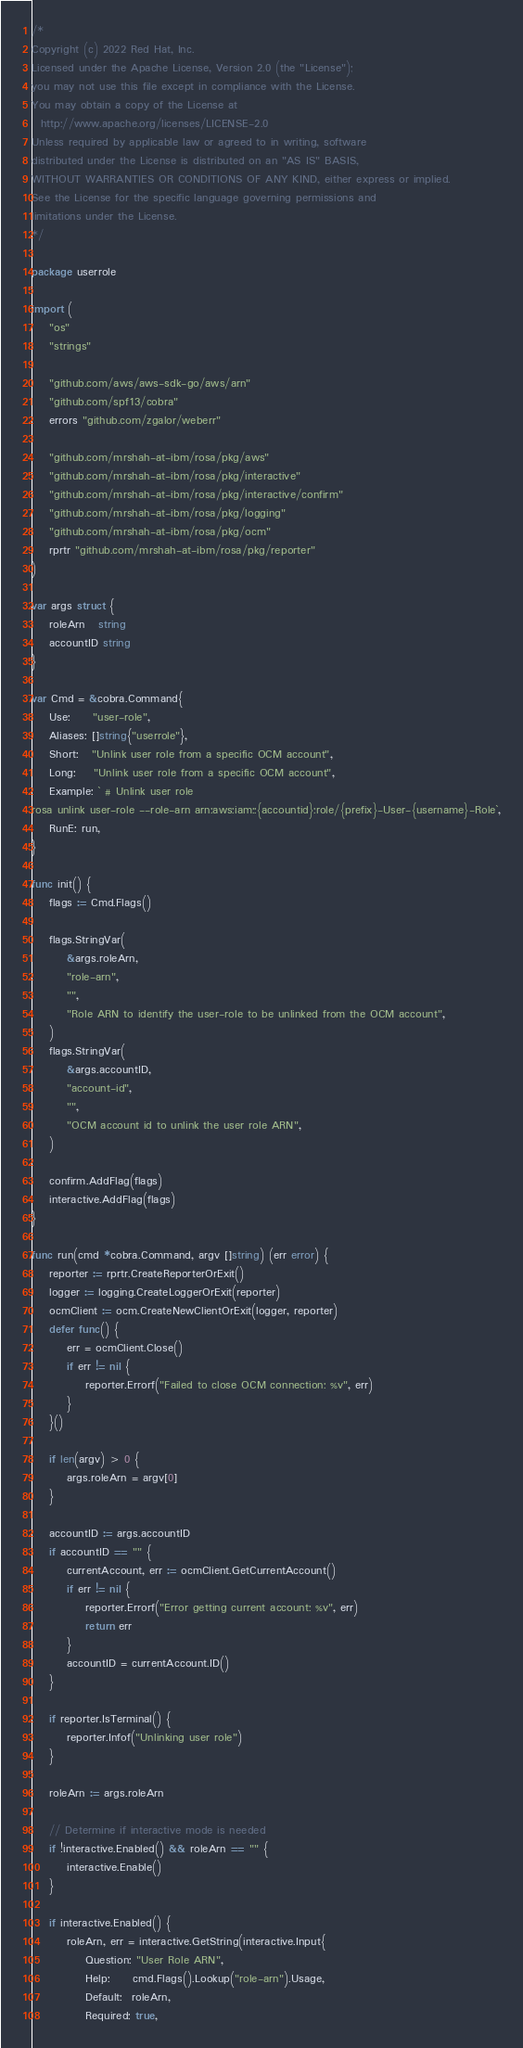Convert code to text. <code><loc_0><loc_0><loc_500><loc_500><_Go_>/*
Copyright (c) 2022 Red Hat, Inc.
Licensed under the Apache License, Version 2.0 (the "License");
you may not use this file except in compliance with the License.
You may obtain a copy of the License at
  http://www.apache.org/licenses/LICENSE-2.0
Unless required by applicable law or agreed to in writing, software
distributed under the License is distributed on an "AS IS" BASIS,
WITHOUT WARRANTIES OR CONDITIONS OF ANY KIND, either express or implied.
See the License for the specific language governing permissions and
limitations under the License.
*/

package userrole

import (
	"os"
	"strings"

	"github.com/aws/aws-sdk-go/aws/arn"
	"github.com/spf13/cobra"
	errors "github.com/zgalor/weberr"

	"github.com/mrshah-at-ibm/rosa/pkg/aws"
	"github.com/mrshah-at-ibm/rosa/pkg/interactive"
	"github.com/mrshah-at-ibm/rosa/pkg/interactive/confirm"
	"github.com/mrshah-at-ibm/rosa/pkg/logging"
	"github.com/mrshah-at-ibm/rosa/pkg/ocm"
	rprtr "github.com/mrshah-at-ibm/rosa/pkg/reporter"
)

var args struct {
	roleArn   string
	accountID string
}

var Cmd = &cobra.Command{
	Use:     "user-role",
	Aliases: []string{"userrole"},
	Short:   "Unlink user role from a specific OCM account",
	Long:    "Unlink user role from a specific OCM account",
	Example: ` # Unlink user role
rosa unlink user-role --role-arn arn:aws:iam::{accountid}:role/{prefix}-User-{username}-Role`,
	RunE: run,
}

func init() {
	flags := Cmd.Flags()

	flags.StringVar(
		&args.roleArn,
		"role-arn",
		"",
		"Role ARN to identify the user-role to be unlinked from the OCM account",
	)
	flags.StringVar(
		&args.accountID,
		"account-id",
		"",
		"OCM account id to unlink the user role ARN",
	)

	confirm.AddFlag(flags)
	interactive.AddFlag(flags)
}

func run(cmd *cobra.Command, argv []string) (err error) {
	reporter := rprtr.CreateReporterOrExit()
	logger := logging.CreateLoggerOrExit(reporter)
	ocmClient := ocm.CreateNewClientOrExit(logger, reporter)
	defer func() {
		err = ocmClient.Close()
		if err != nil {
			reporter.Errorf("Failed to close OCM connection: %v", err)
		}
	}()

	if len(argv) > 0 {
		args.roleArn = argv[0]
	}

	accountID := args.accountID
	if accountID == "" {
		currentAccount, err := ocmClient.GetCurrentAccount()
		if err != nil {
			reporter.Errorf("Error getting current account: %v", err)
			return err
		}
		accountID = currentAccount.ID()
	}

	if reporter.IsTerminal() {
		reporter.Infof("Unlinking user role")
	}

	roleArn := args.roleArn

	// Determine if interactive mode is needed
	if !interactive.Enabled() && roleArn == "" {
		interactive.Enable()
	}

	if interactive.Enabled() {
		roleArn, err = interactive.GetString(interactive.Input{
			Question: "User Role ARN",
			Help:     cmd.Flags().Lookup("role-arn").Usage,
			Default:  roleArn,
			Required: true,</code> 